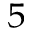<formula> <loc_0><loc_0><loc_500><loc_500>^ { 5 }</formula> 